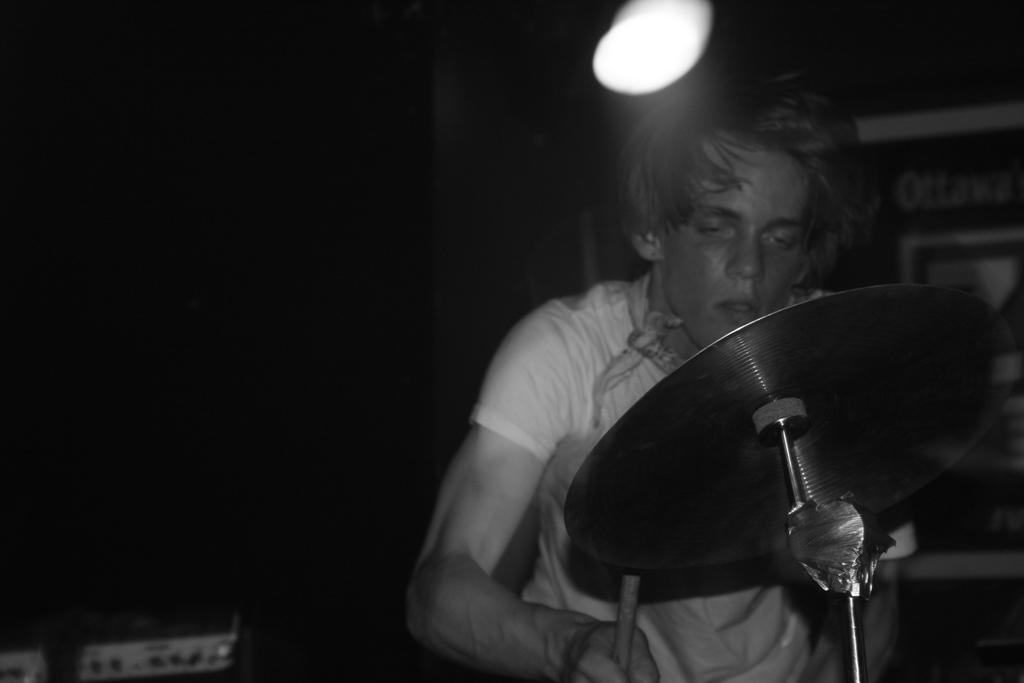Can you describe this image briefly? In this picture we can observe a man wearing a T shirt. In front of him we can observe drums. In the background we can observe light. The background is dark. This is a black and white image. 